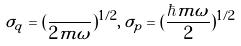<formula> <loc_0><loc_0><loc_500><loc_500>\sigma _ { q } = ( \frac { } { 2 m \omega } ) ^ { 1 / 2 } , \, \sigma _ { p } = ( \frac { \hbar { m } \omega } { 2 } ) ^ { 1 / 2 }</formula> 